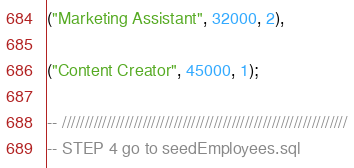Convert code to text. <code><loc_0><loc_0><loc_500><loc_500><_SQL_>("Marketing Assistant", 32000, 2),

("Content Creator", 45000, 1);

-- ////////////////////////////////////////////////////////////////
-- STEP 4 go to seedEmployees.sql</code> 